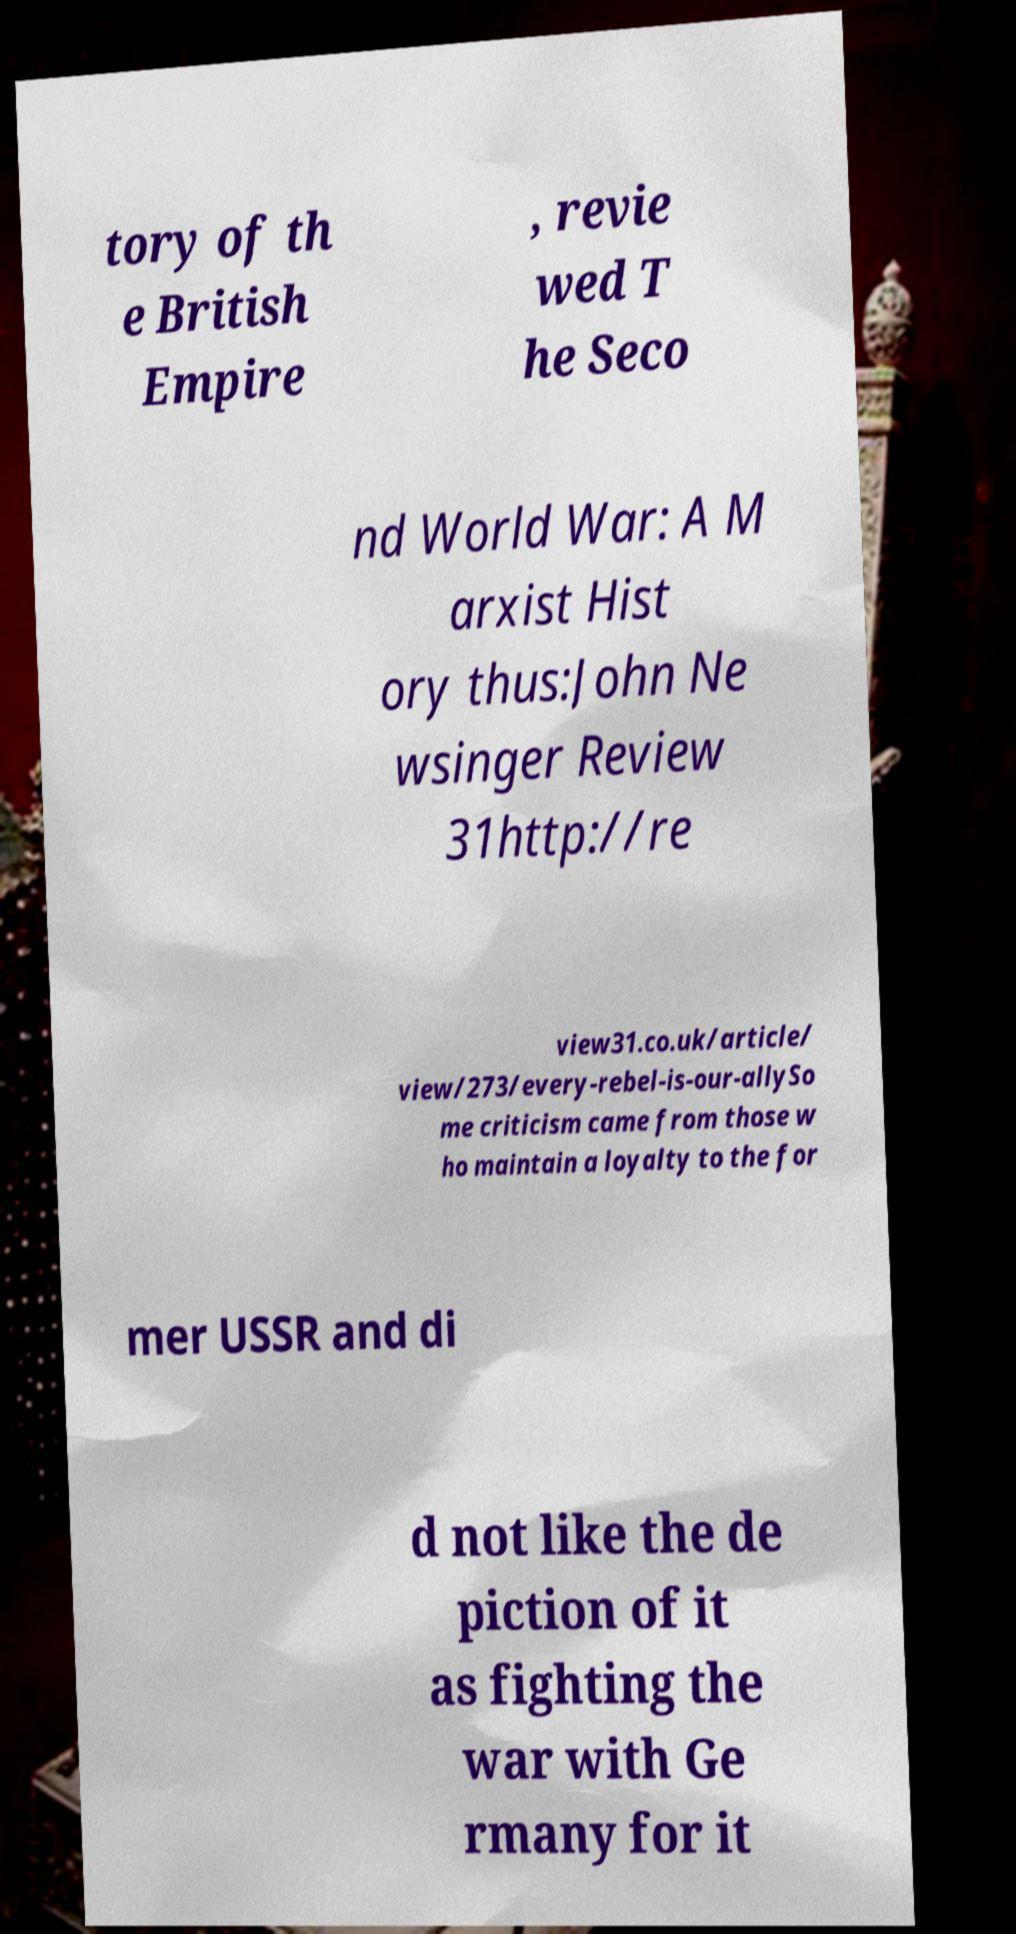Please read and relay the text visible in this image. What does it say? tory of th e British Empire , revie wed T he Seco nd World War: A M arxist Hist ory thus:John Ne wsinger Review 31http://re view31.co.uk/article/ view/273/every-rebel-is-our-allySo me criticism came from those w ho maintain a loyalty to the for mer USSR and di d not like the de piction of it as fighting the war with Ge rmany for it 